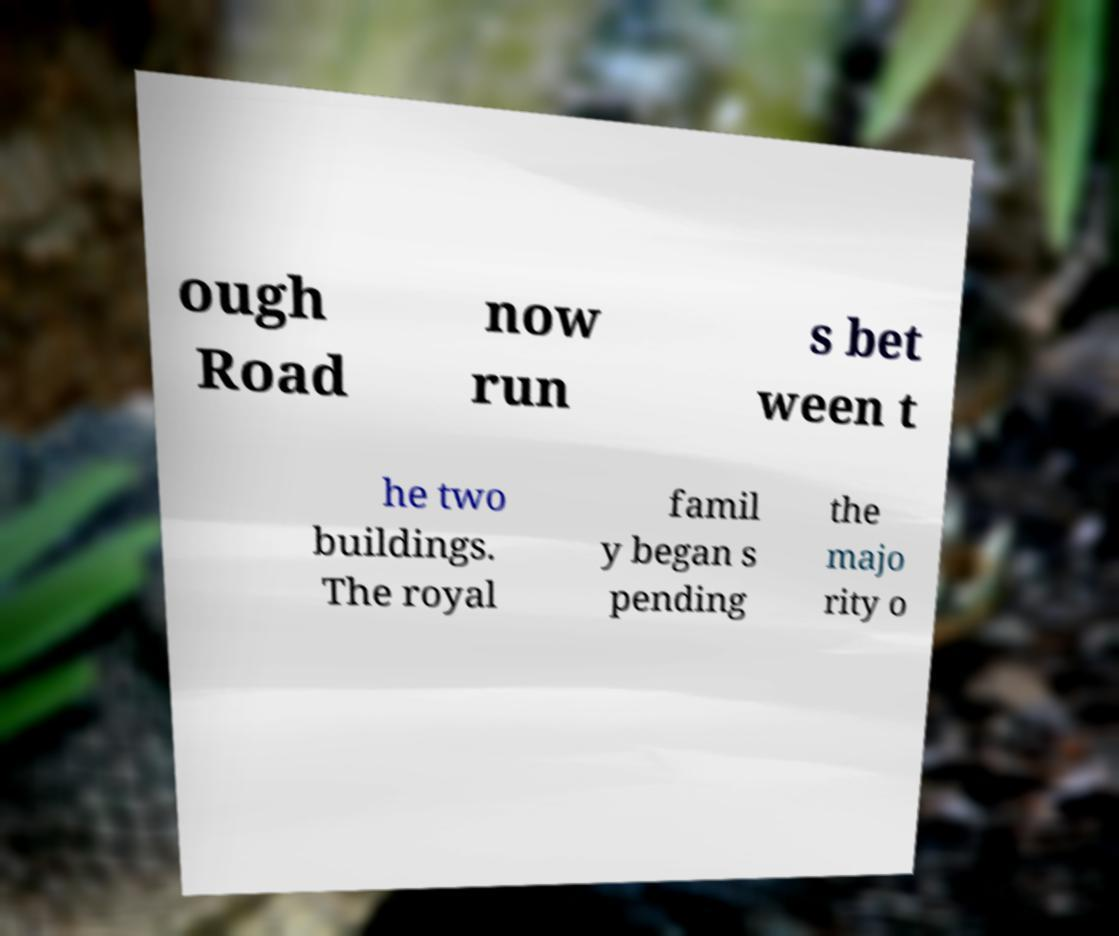What messages or text are displayed in this image? I need them in a readable, typed format. ough Road now run s bet ween t he two buildings. The royal famil y began s pending the majo rity o 